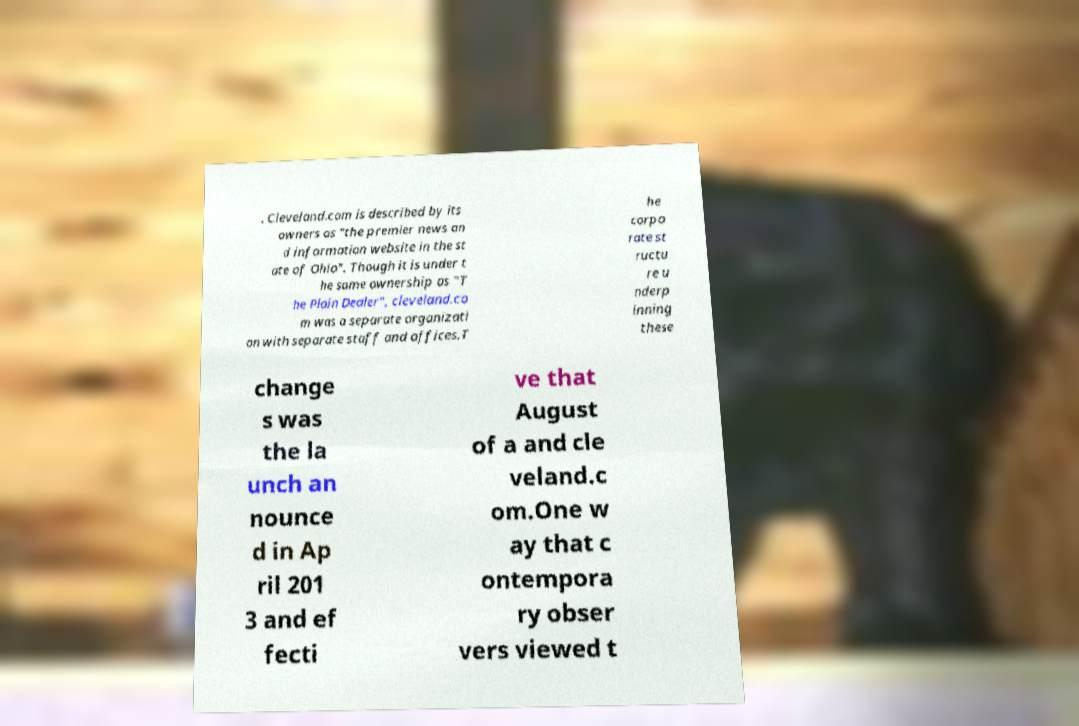Please read and relay the text visible in this image. What does it say? . Cleveland.com is described by its owners as "the premier news an d information website in the st ate of Ohio". Though it is under t he same ownership as "T he Plain Dealer", cleveland.co m was a separate organizati on with separate staff and offices.T he corpo rate st ructu re u nderp inning these change s was the la unch an nounce d in Ap ril 201 3 and ef fecti ve that August of a and cle veland.c om.One w ay that c ontempora ry obser vers viewed t 